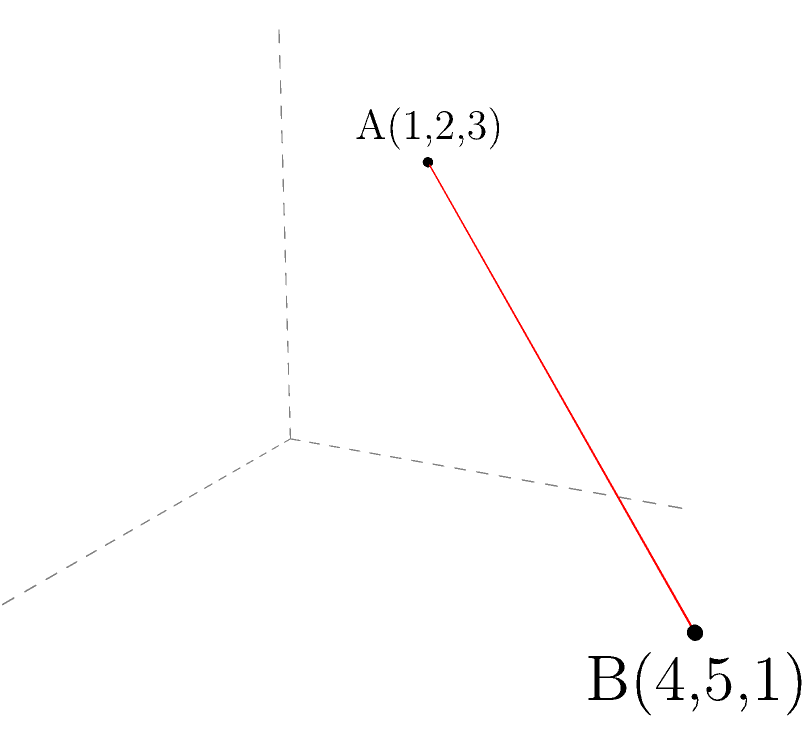As a literary agent evaluating a geometry textbook, you come across a problem involving three-dimensional coordinates. Two points, A(1,2,3) and B(4,5,1), are given in a three-dimensional coordinate system. Calculate the distance between these two points to assess the clarity and accuracy of the textbook's content. Round your answer to two decimal places. To calculate the distance between two points in a three-dimensional coordinate system, we use the three-dimensional distance formula:

$$d = \sqrt{(x_2-x_1)^2 + (y_2-y_1)^2 + (z_2-z_1)^2}$$

Where $(x_1,y_1,z_1)$ are the coordinates of the first point and $(x_2,y_2,z_2)$ are the coordinates of the second point.

Given:
Point A: $(1,2,3)$
Point B: $(4,5,1)$

Step 1: Identify the coordinates
$x_1 = 1$, $y_1 = 2$, $z_1 = 3$
$x_2 = 4$, $y_2 = 5$, $z_2 = 1$

Step 2: Substitute the values into the formula
$$d = \sqrt{(4-1)^2 + (5-2)^2 + (1-3)^2}$$

Step 3: Calculate the differences
$$d = \sqrt{3^2 + 3^2 + (-2)^2}$$

Step 4: Square the differences
$$d = \sqrt{9 + 9 + 4}$$

Step 5: Add the squared differences
$$d = \sqrt{22}$$

Step 6: Calculate the square root and round to two decimal places
$$d \approx 4.69$$

Therefore, the distance between points A and B is approximately 4.69 units.
Answer: 4.69 units 